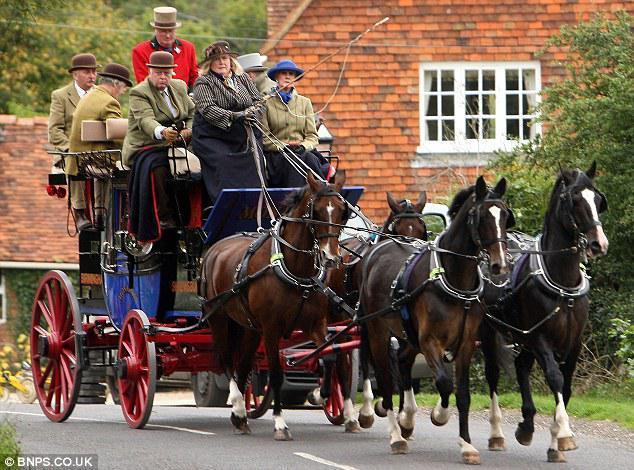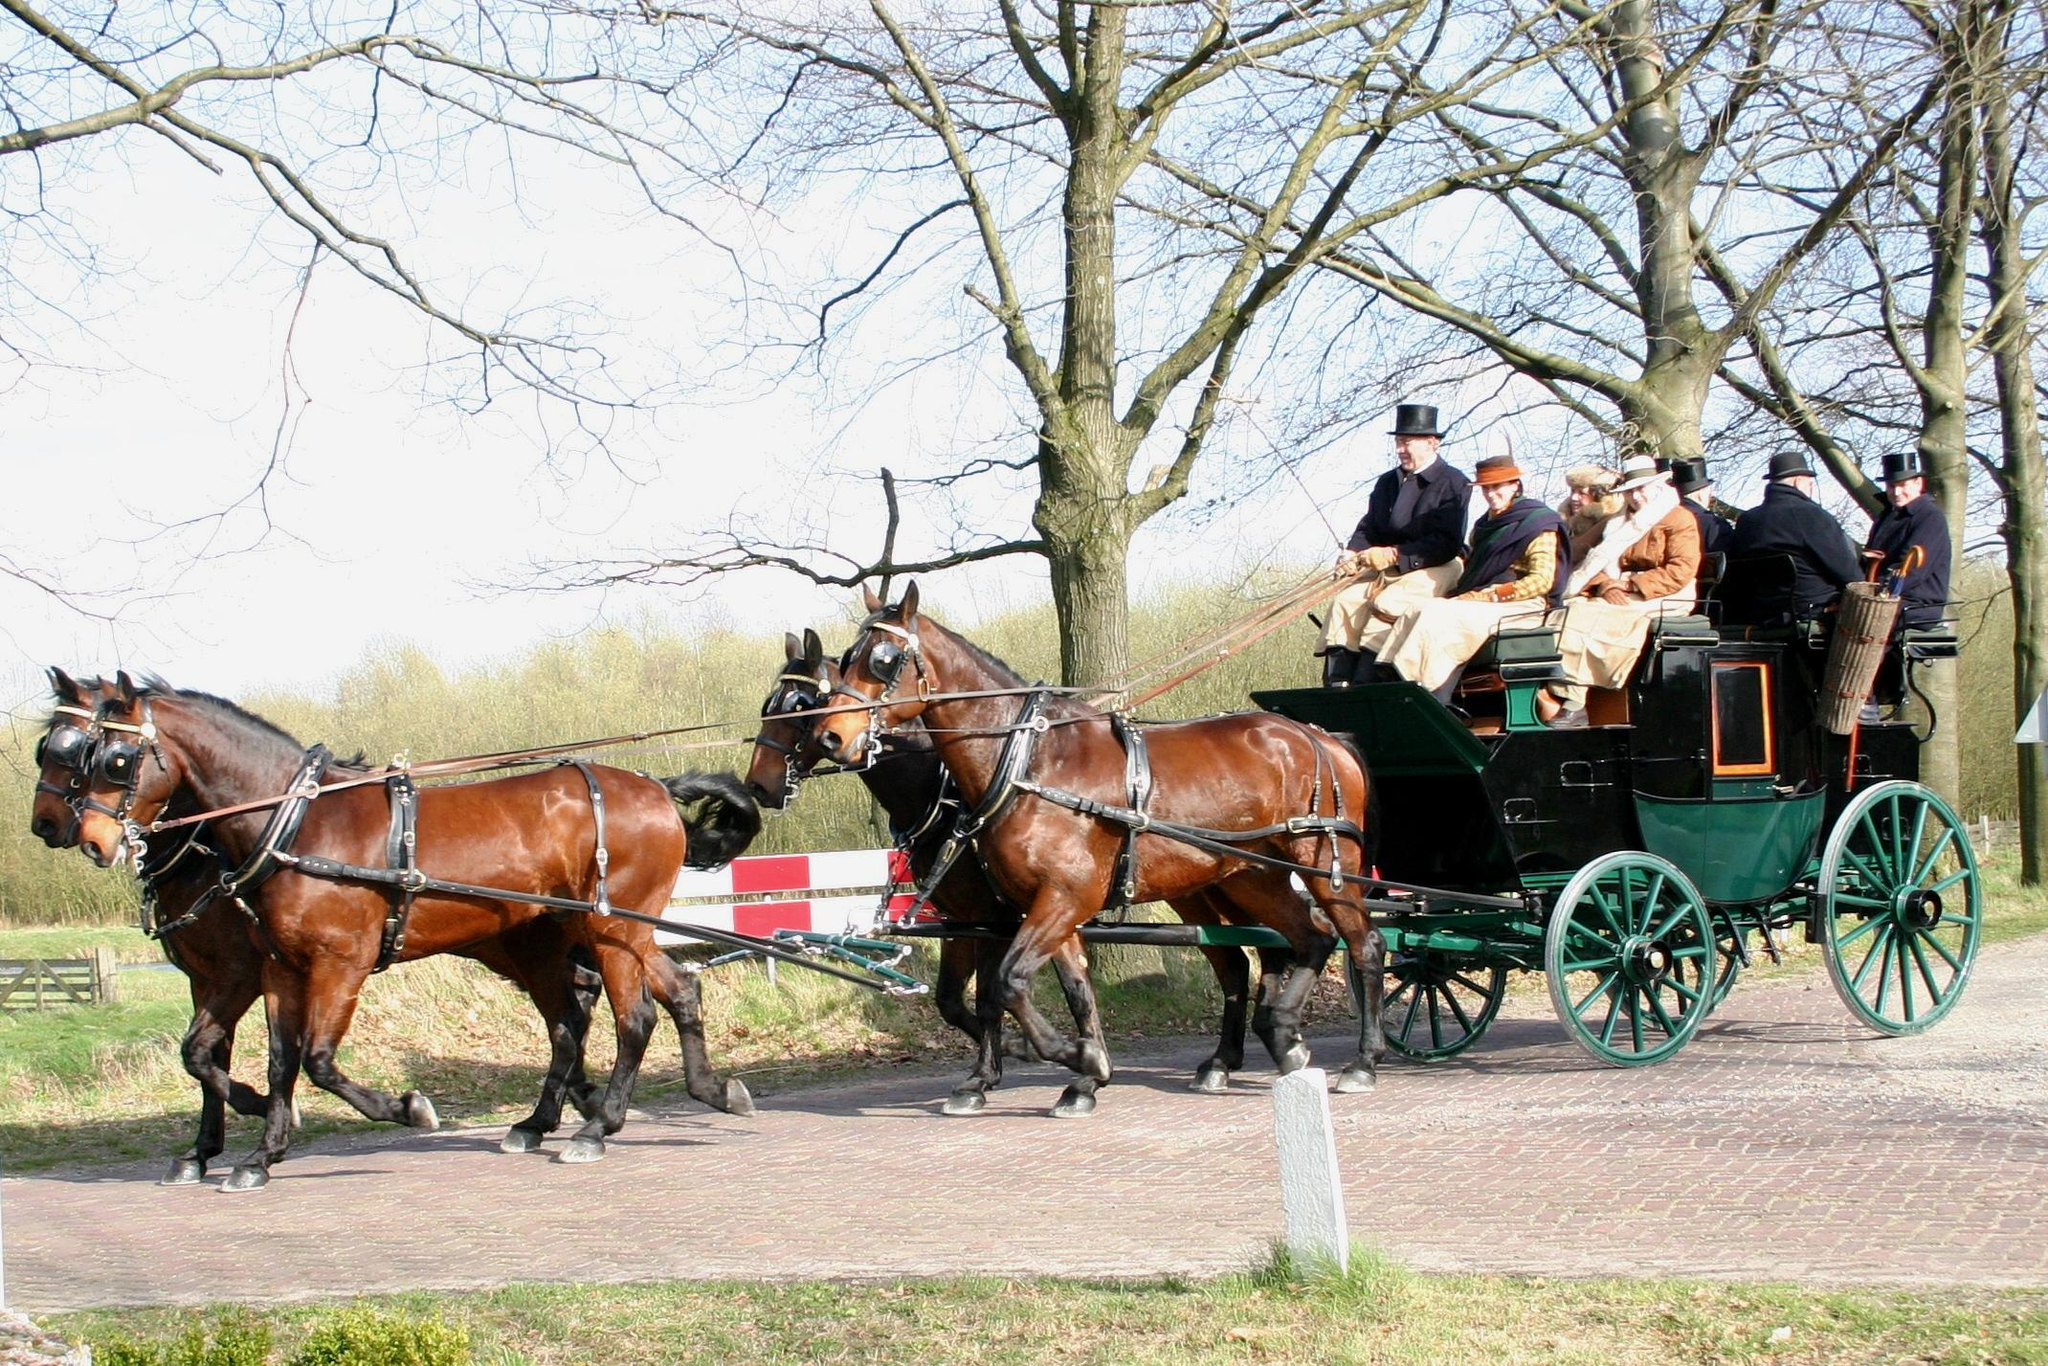The first image is the image on the left, the second image is the image on the right. For the images shown, is this caption "The horse drawn carriage in the image on the right is against a plain white background." true? Answer yes or no. No. The first image is the image on the left, the second image is the image on the right. Assess this claim about the two images: "There is a carriage hitched to a pair of white horses.". Correct or not? Answer yes or no. No. 